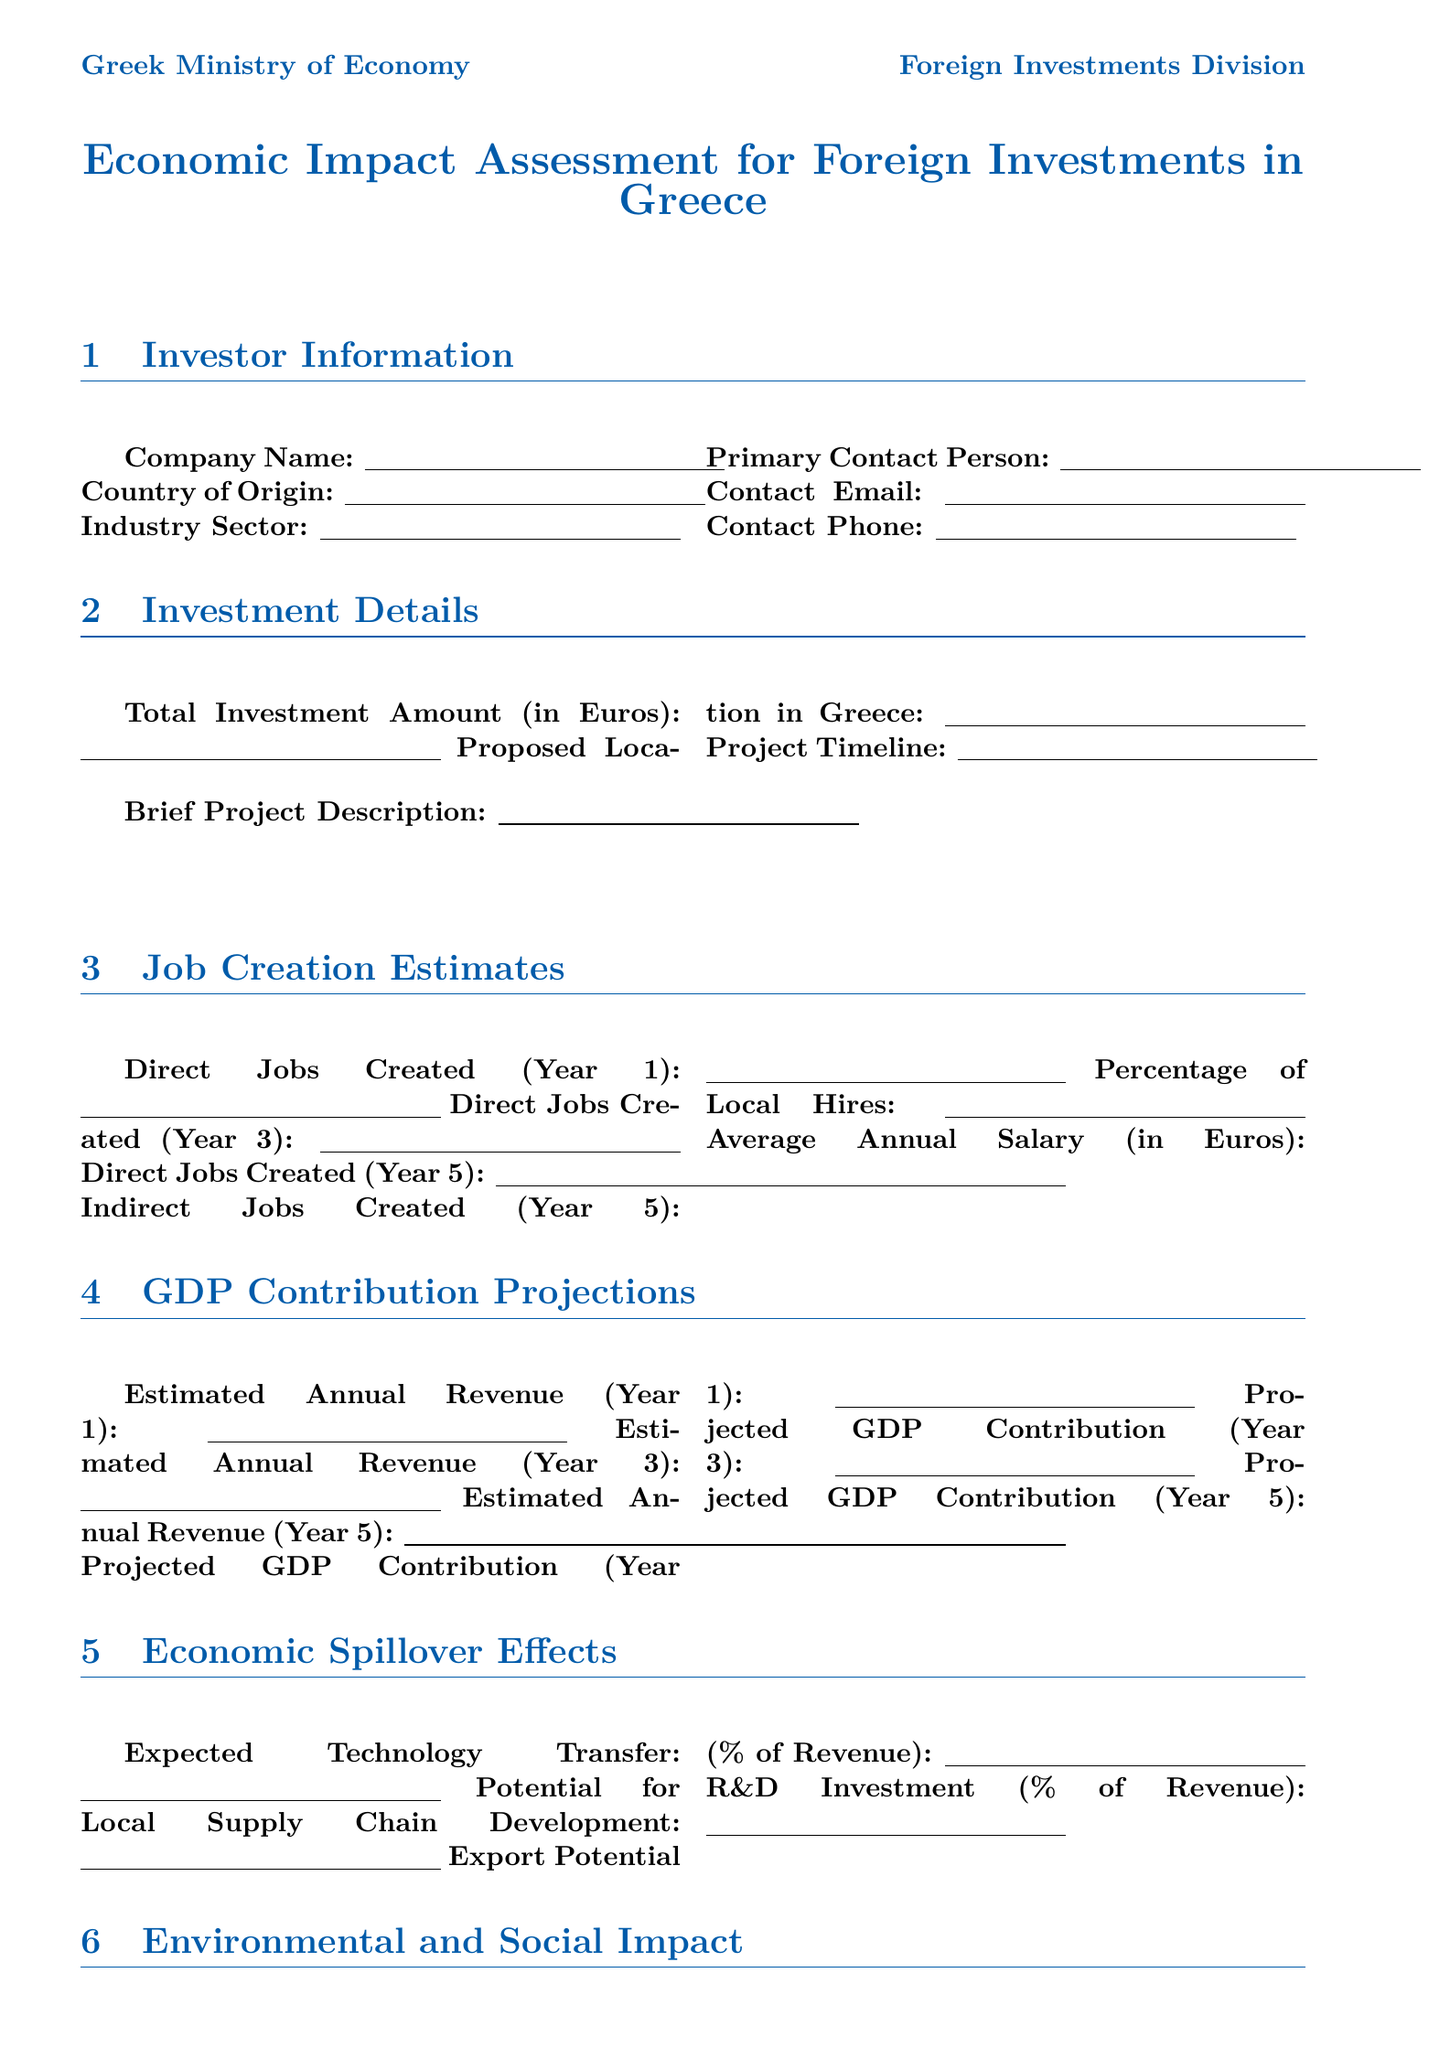What is the company name? The company name is provided by the investor in the form.
Answer: Company Name What is the total investment amount in Euros? The total investment amount reflects the financial commitment of the investor in euros.
Answer: Total Investment Amount (in Euros) How many direct jobs are created in Year 5? This information estimates the total jobs to be created by the investment after five years.
Answer: Direct Jobs Created (Year 5) What is the projected GDP contribution in Year 3? This projection represents the estimated impact of the investment on Greece's GDP three years after its initiation.
Answer: Projected GDP Contribution (Year 3) What percentage of local hires is anticipated? This field estimates the ratio of local hires compared to total jobs created.
Answer: Percentage of Local Hires What is the current unemployment rate? This statistic reflects the economic condition in Greece and is a key economic indicator.
Answer: 12.8% Which agency is responsible for investment promotion? This question identifies the government body dedicated to promoting investment and trade.
Answer: Enterprise Greece Is renewable energy a priority sector? This question checks whether the sector is recognized as a key area for foreign investment in Greece.
Answer: Yes What is the expected carbon footprint per year? This field indicates the environmental impact related to the investment and is part of the assessment.
Answer: Estimated Carbon Footprint (tons CO2e/year) 